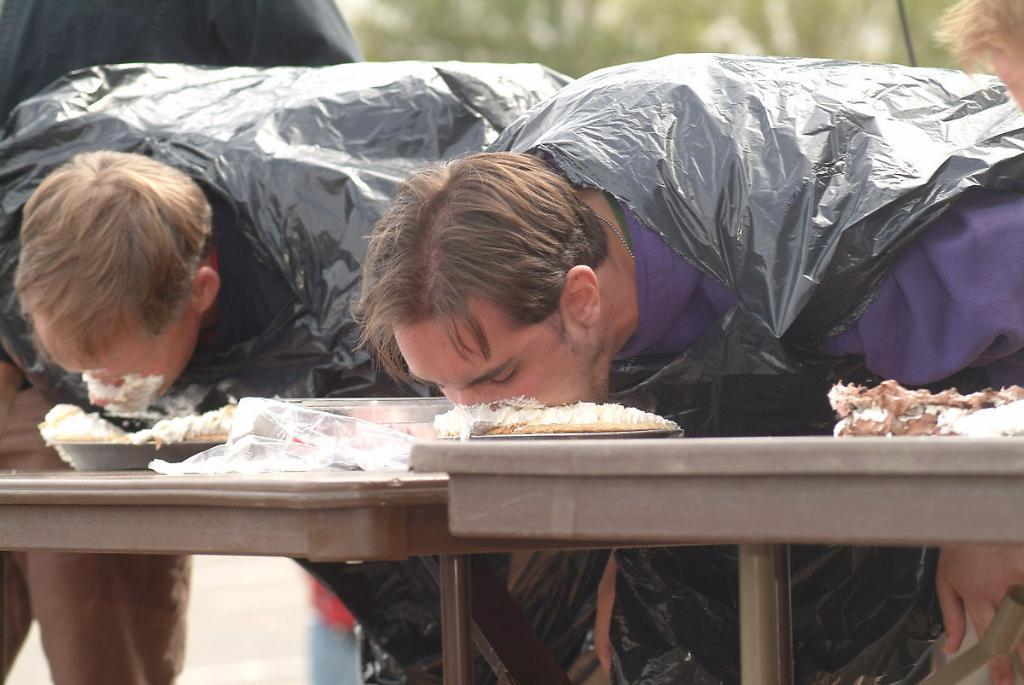What type of furniture can be seen in the image? There are tables in the image. What else is present on the tables? There is food and objects on the table. Can you describe the people in the foreground of the image? There are people in the foreground of the image. What might be visible in the background of the image? There might be trees in the background of the image. What type of key is being discussed by the people in the image? There is no mention of a key or any discussion in the image. Can you see any visible wrist movements in the image? There is no indication of wrist movements or any specific body language in the image. 